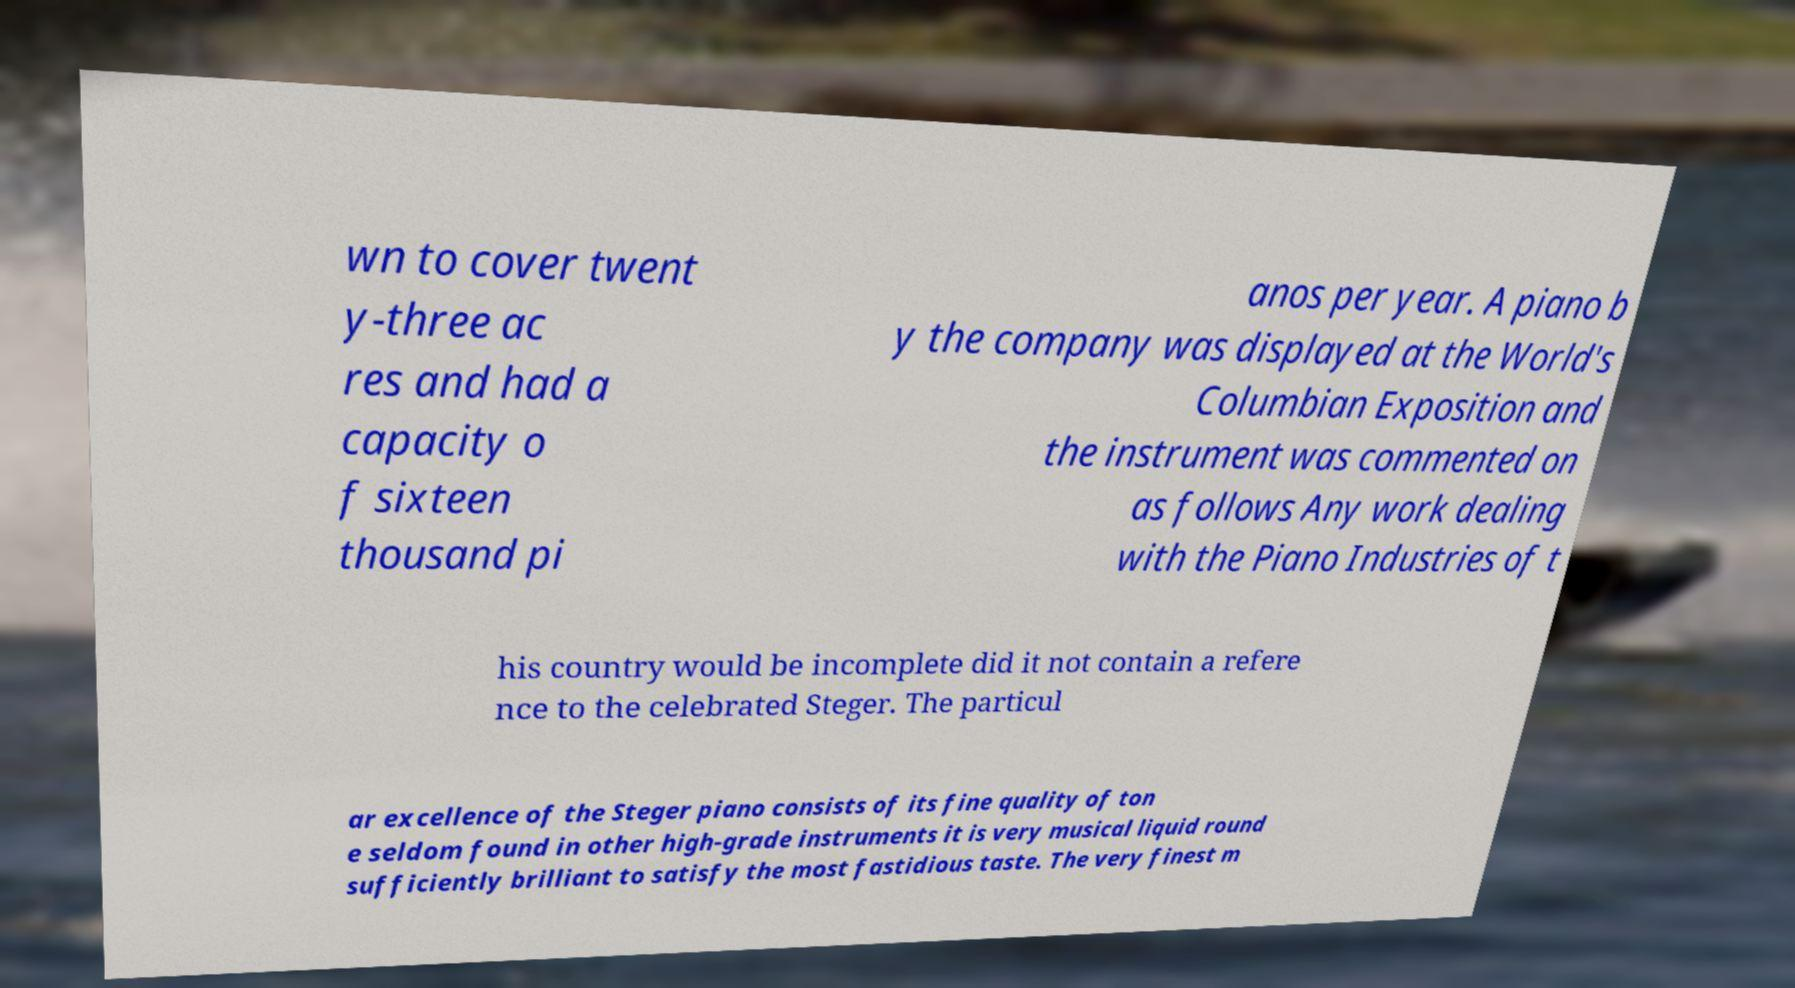Please identify and transcribe the text found in this image. wn to cover twent y-three ac res and had a capacity o f sixteen thousand pi anos per year. A piano b y the company was displayed at the World's Columbian Exposition and the instrument was commented on as follows Any work dealing with the Piano Industries of t his country would be incomplete did it not contain a refere nce to the celebrated Steger. The particul ar excellence of the Steger piano consists of its fine quality of ton e seldom found in other high-grade instruments it is very musical liquid round sufficiently brilliant to satisfy the most fastidious taste. The very finest m 